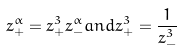<formula> <loc_0><loc_0><loc_500><loc_500>z _ { + } ^ { \alpha } = z _ { + } ^ { 3 } z _ { - } ^ { \alpha } a n d z _ { + } ^ { 3 } = \frac { 1 } { z _ { - } ^ { 3 } }</formula> 